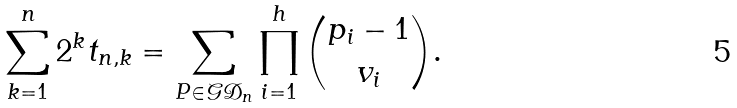Convert formula to latex. <formula><loc_0><loc_0><loc_500><loc_500>\sum _ { k = 1 } ^ { n } 2 ^ { k } t _ { n , k } = \sum _ { P \in \mathcal { G D } _ { n } } \prod _ { i = 1 } ^ { h } { p _ { i } - 1 \choose v _ { i } } .</formula> 